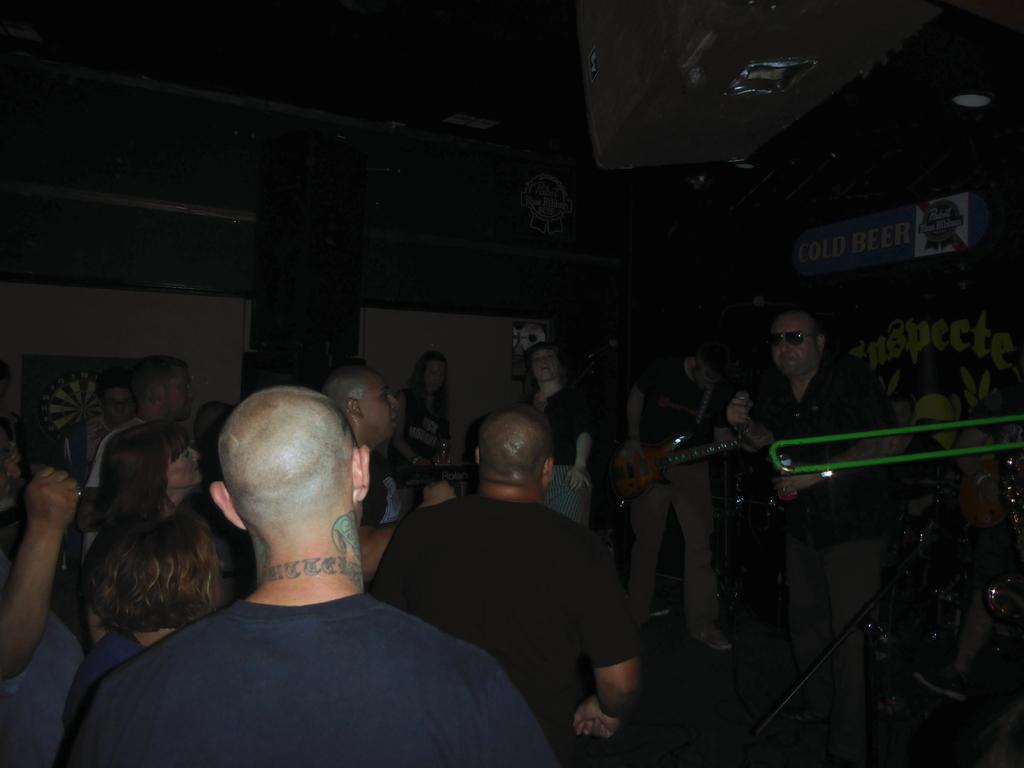Please provide a concise description of this image. In this image we can see group of persons are standing, here a man is holding a guitar in the hands, here a man is holding a microphone in the hands, here it is dark. 